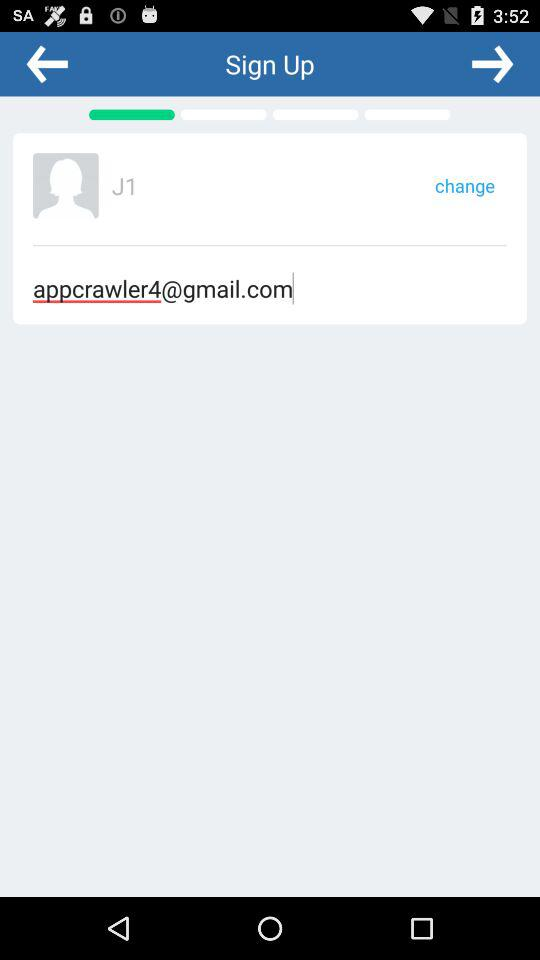What is the name of the user? The user name is J1. 